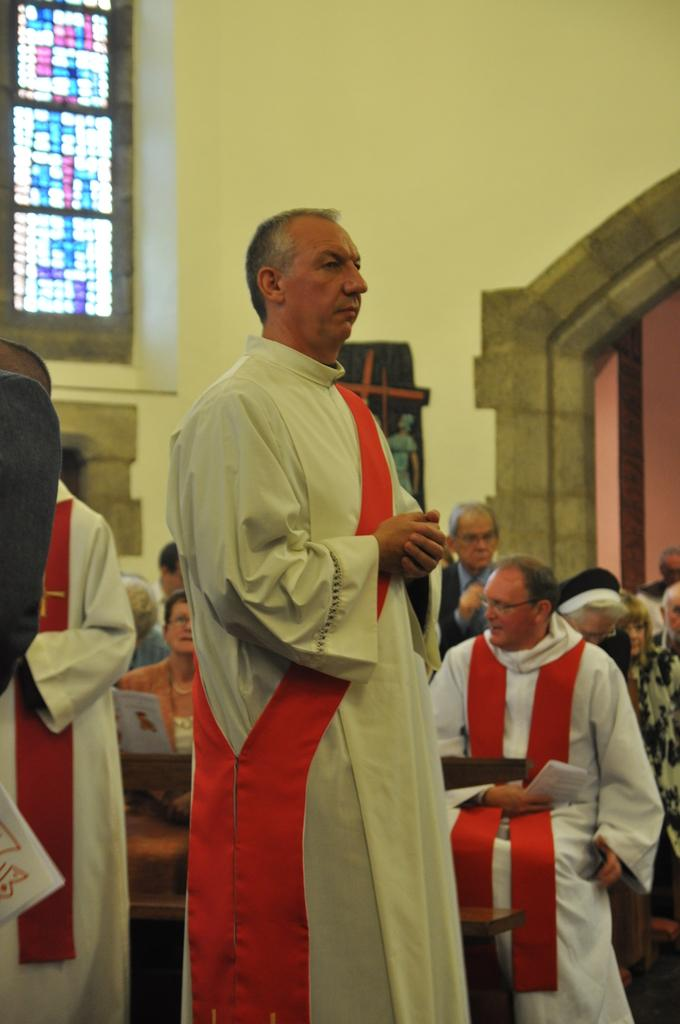What are the people in the image doing? There are people sitting and standing in the image. What can be seen in the background of the image? There is a wall with an arch and a glass window with a design in the background of the image. What type of pot is being used to cook the stew in the image? There is no pot or stew present in the image; it features people sitting and standing with a background of a wall and a glass window. What policy changes has the governor implemented in the image? There is no governor or policy changes mentioned in the image; it focuses on people and their positions. 